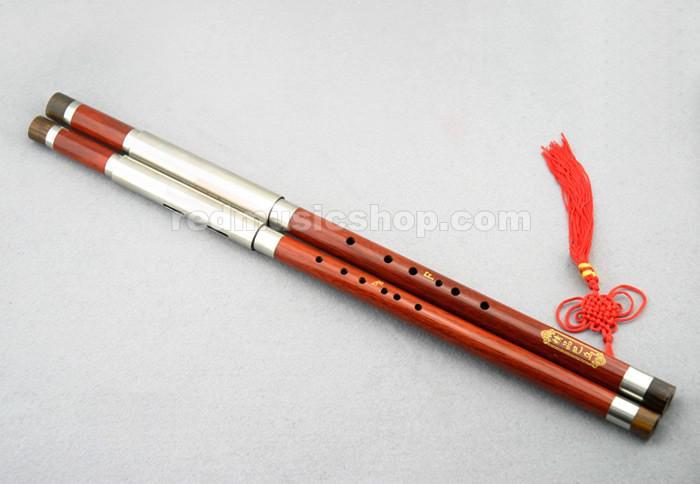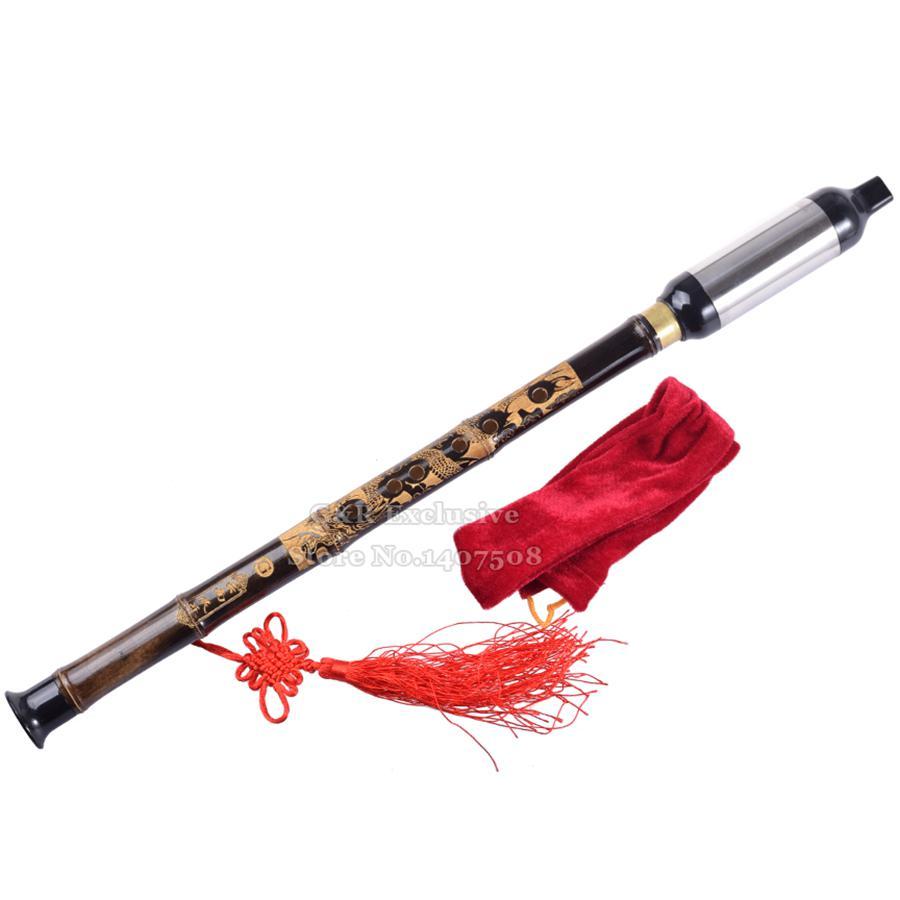The first image is the image on the left, the second image is the image on the right. For the images shown, is this caption "there is a flute with a red tassel hanging from the lower half and a soft fabric pouch next to it" true? Answer yes or no. Yes. 